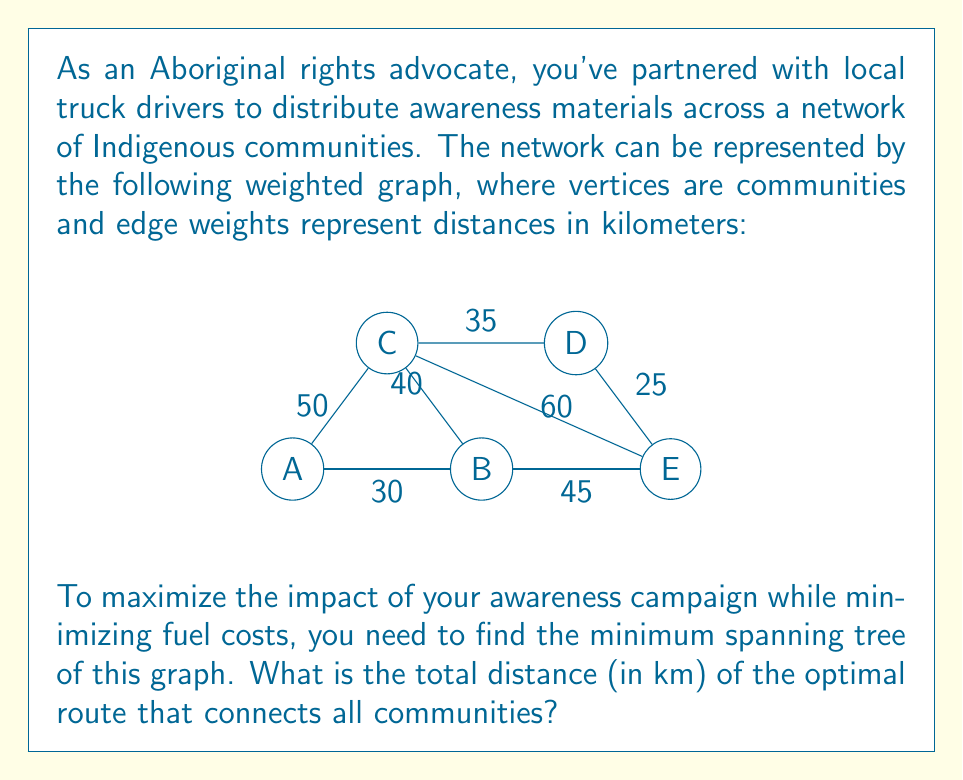Give your solution to this math problem. To solve this problem, we'll use Kruskal's algorithm to find the minimum spanning tree (MST) of the given graph. This will give us the optimal route that connects all communities with the minimum total distance.

Step 1: List all edges and their weights in ascending order:
1. B-D: 25 km
2. A-B: 30 km
3. C-D: 35 km
4. B-C: 40 km
5. B-E: 45 km
6. A-C: 50 km
7. C-E: 60 km

Step 2: Apply Kruskal's algorithm:
1. Add B-D (25 km)
2. Add A-B (30 km)
3. Add C-D (35 km)
4. Add B-E (45 km)

At this point, we have connected all vertices (communities) without forming any cycles. The algorithm stops here.

Step 3: Calculate the total distance of the MST:
Total distance = 25 + 30 + 35 + 45 = 135 km

Therefore, the optimal route that connects all communities has a total distance of 135 km.

This solution ensures that awareness materials can be distributed to all communities while minimizing the total distance traveled by the truck drivers, thus reducing fuel costs and environmental impact.
Answer: 135 km 